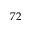Convert formula to latex. <formula><loc_0><loc_0><loc_500><loc_500>7 2</formula> 